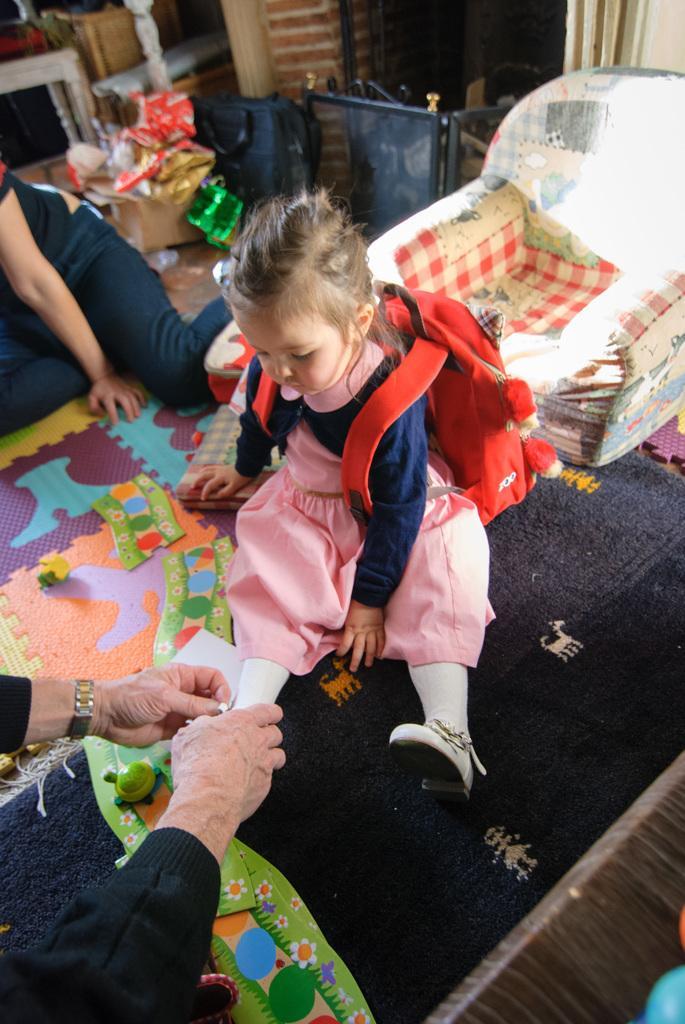Please provide a concise description of this image. In the picture we can see a person's hand holding a child's shoe who is wearing a pink color dress and a red color backpack is sitting on the carpet. In the background, we can see a person sitting on the floor and we can a chair here and we see a few more objects. 